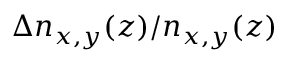Convert formula to latex. <formula><loc_0><loc_0><loc_500><loc_500>\Delta n _ { x , y } ( z ) / n _ { x , y } ( z )</formula> 